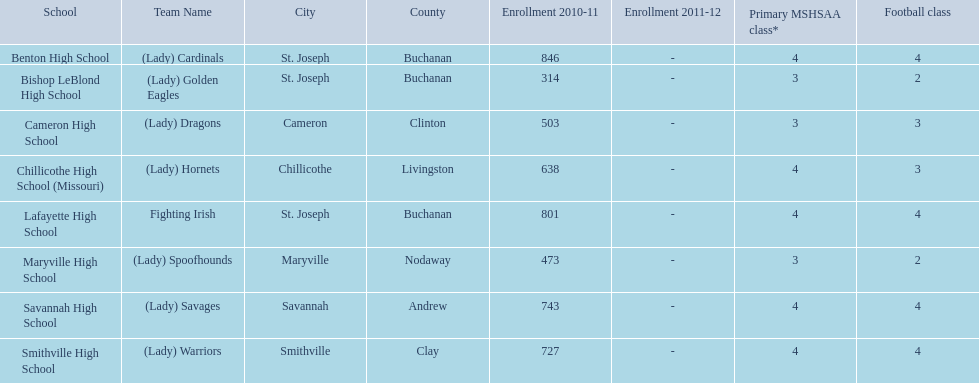What is the lowest number of students enrolled at a school as listed here? 314. What school has 314 students enrolled? Bishop LeBlond High School. 